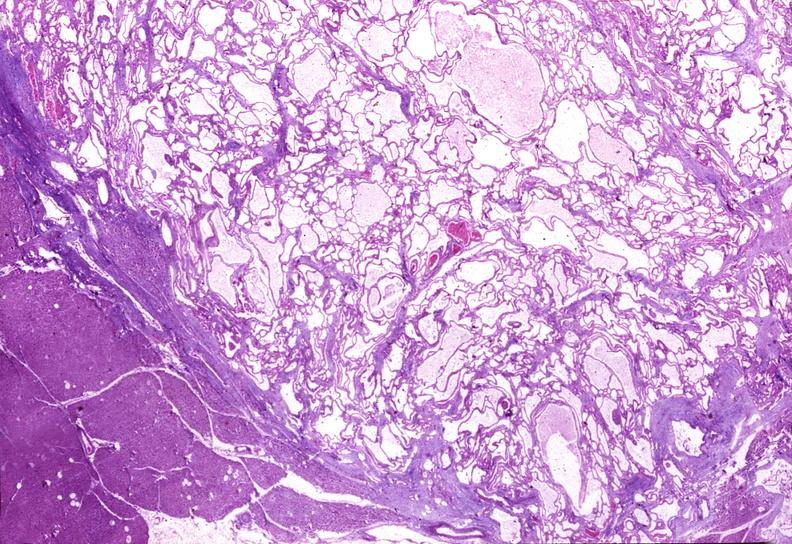s nodules present?
Answer the question using a single word or phrase. No 